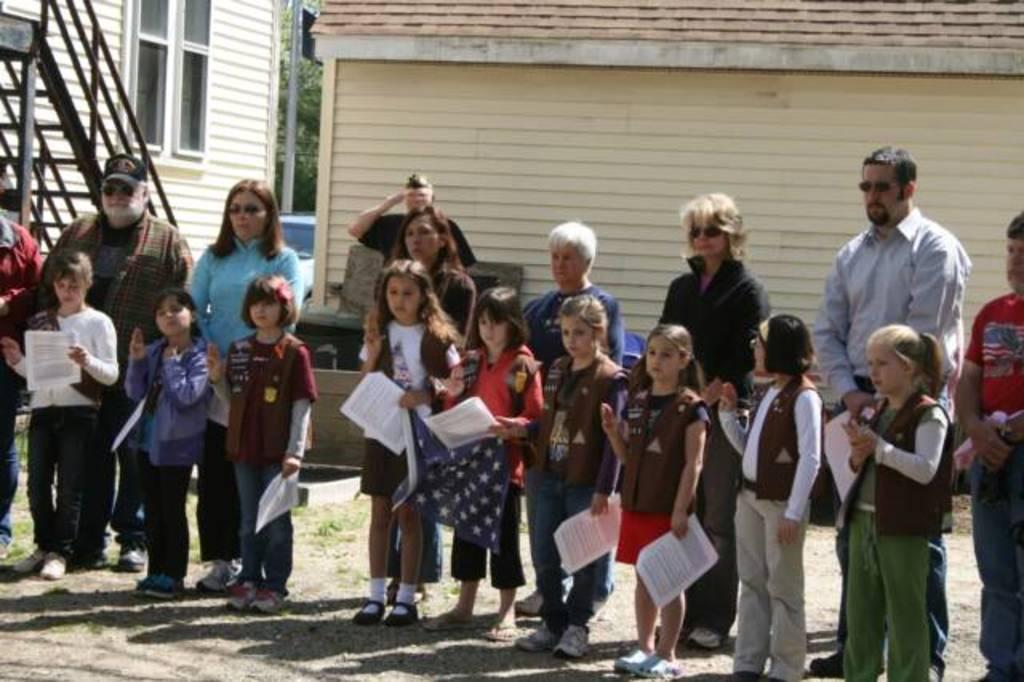Describe this image in one or two sentences. In this image we can see few people standing in the ground and some of them are holding papers in their hands and in the background there is a building and trees. 